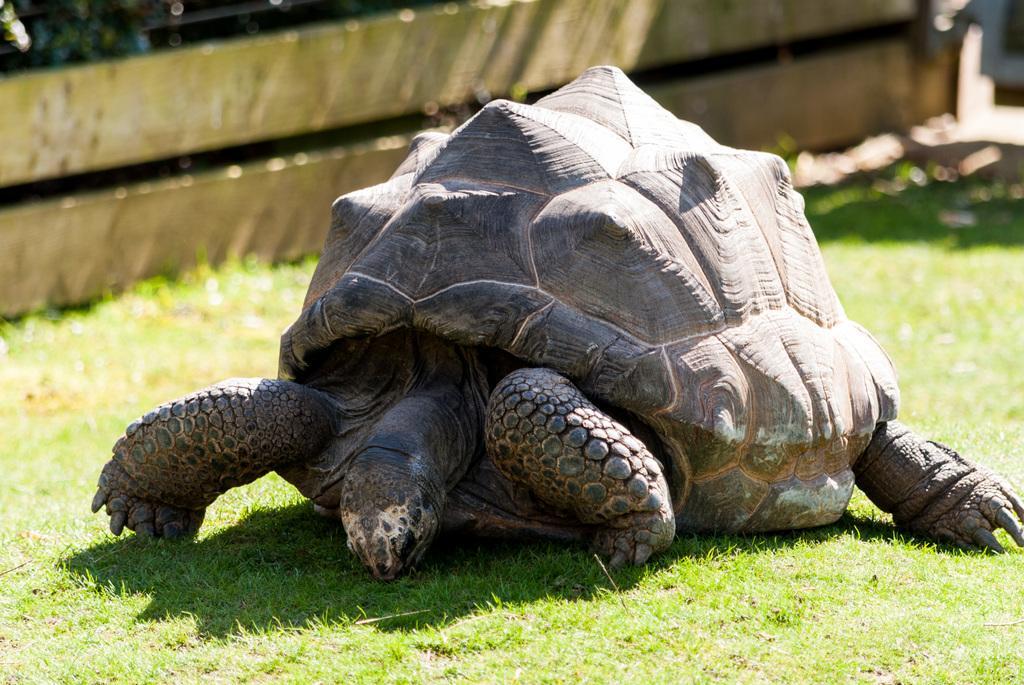Please provide a concise description of this image. In this image there is a tortoise on the ground. There is grass on the ground. In the background there is a wooden wall. 